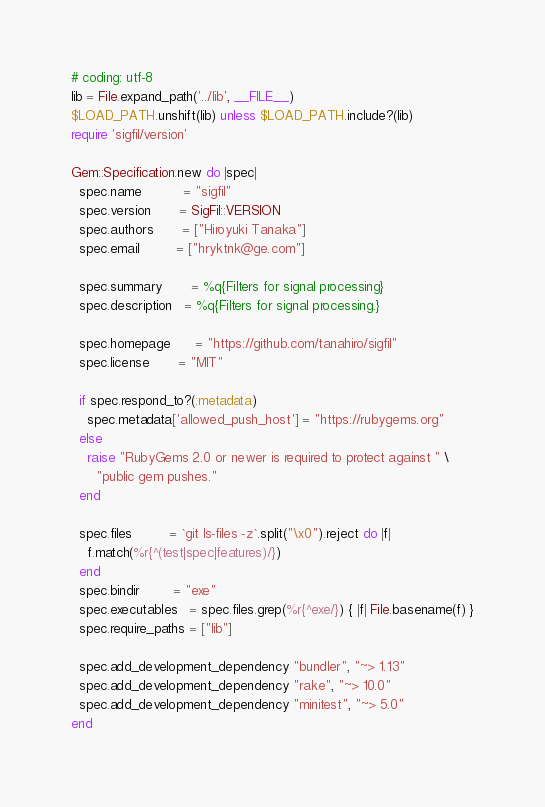Convert code to text. <code><loc_0><loc_0><loc_500><loc_500><_Ruby_># coding: utf-8
lib = File.expand_path('../lib', __FILE__)
$LOAD_PATH.unshift(lib) unless $LOAD_PATH.include?(lib)
require 'sigfil/version'

Gem::Specification.new do |spec|
  spec.name          = "sigfil"
  spec.version       = SigFil::VERSION
  spec.authors       = ["Hiroyuki Tanaka"]
  spec.email         = ["hryktnk@ge.com"]

  spec.summary       = %q{Filters for signal processing}
  spec.description   = %q{Filters for signal processing.}

  spec.homepage      = "https://github.com/tanahiro/sigfil"
  spec.license       = "MIT"

  if spec.respond_to?(:metadata)
    spec.metadata['allowed_push_host'] = "https://rubygems.org"
  else
    raise "RubyGems 2.0 or newer is required to protect against " \
      "public gem pushes."
  end

  spec.files         = `git ls-files -z`.split("\x0").reject do |f|
    f.match(%r{^(test|spec|features)/})
  end
  spec.bindir        = "exe"
  spec.executables   = spec.files.grep(%r{^exe/}) { |f| File.basename(f) }
  spec.require_paths = ["lib"]

  spec.add_development_dependency "bundler", "~> 1.13"
  spec.add_development_dependency "rake", "~> 10.0"
  spec.add_development_dependency "minitest", "~> 5.0"
end
</code> 